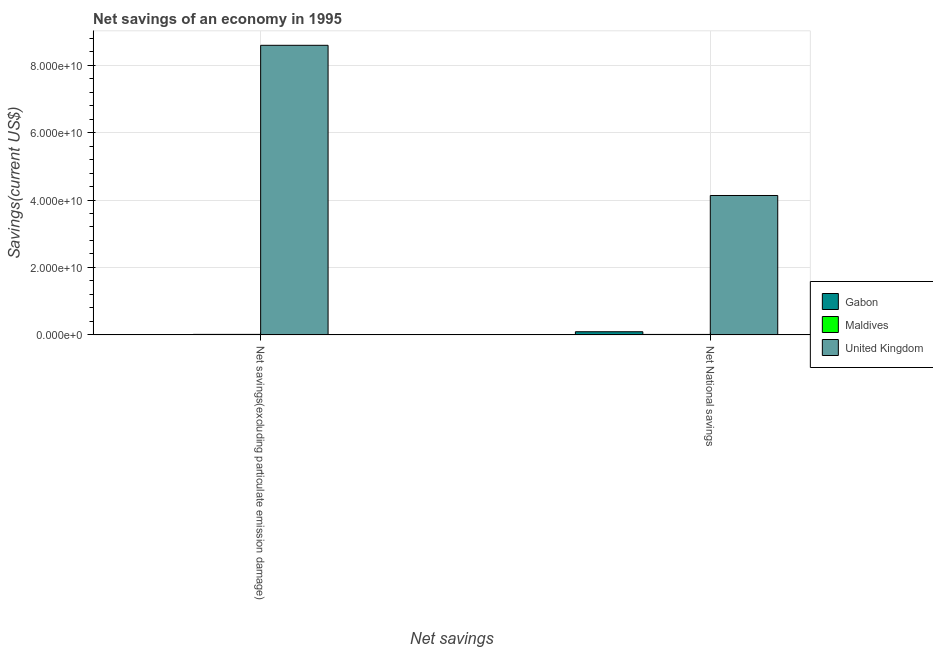How many groups of bars are there?
Provide a short and direct response. 2. Are the number of bars on each tick of the X-axis equal?
Keep it short and to the point. No. How many bars are there on the 1st tick from the left?
Offer a terse response. 2. What is the label of the 1st group of bars from the left?
Make the answer very short. Net savings(excluding particulate emission damage). What is the net savings(excluding particulate emission damage) in Maldives?
Make the answer very short. 1.51e+08. Across all countries, what is the maximum net national savings?
Provide a short and direct response. 4.13e+1. Across all countries, what is the minimum net savings(excluding particulate emission damage)?
Your answer should be compact. 0. What is the total net national savings in the graph?
Provide a short and direct response. 4.24e+1. What is the difference between the net savings(excluding particulate emission damage) in Maldives and that in United Kingdom?
Your answer should be compact. -8.57e+1. What is the difference between the net savings(excluding particulate emission damage) in United Kingdom and the net national savings in Maldives?
Your response must be concise. 8.58e+1. What is the average net national savings per country?
Keep it short and to the point. 1.41e+1. What is the difference between the net national savings and net savings(excluding particulate emission damage) in United Kingdom?
Your answer should be compact. -4.45e+1. What is the ratio of the net national savings in Maldives to that in United Kingdom?
Provide a succinct answer. 0. Are all the bars in the graph horizontal?
Give a very brief answer. No. How many countries are there in the graph?
Your response must be concise. 3. What is the difference between two consecutive major ticks on the Y-axis?
Keep it short and to the point. 2.00e+1. Are the values on the major ticks of Y-axis written in scientific E-notation?
Provide a succinct answer. Yes. Does the graph contain grids?
Provide a short and direct response. Yes. Where does the legend appear in the graph?
Offer a very short reply. Center right. How many legend labels are there?
Provide a succinct answer. 3. How are the legend labels stacked?
Keep it short and to the point. Vertical. What is the title of the graph?
Keep it short and to the point. Net savings of an economy in 1995. Does "Seychelles" appear as one of the legend labels in the graph?
Give a very brief answer. No. What is the label or title of the X-axis?
Keep it short and to the point. Net savings. What is the label or title of the Y-axis?
Offer a very short reply. Savings(current US$). What is the Savings(current US$) in Gabon in Net savings(excluding particulate emission damage)?
Ensure brevity in your answer.  0. What is the Savings(current US$) of Maldives in Net savings(excluding particulate emission damage)?
Make the answer very short. 1.51e+08. What is the Savings(current US$) in United Kingdom in Net savings(excluding particulate emission damage)?
Keep it short and to the point. 8.59e+1. What is the Savings(current US$) in Gabon in Net National savings?
Make the answer very short. 9.35e+08. What is the Savings(current US$) of Maldives in Net National savings?
Keep it short and to the point. 1.36e+08. What is the Savings(current US$) of United Kingdom in Net National savings?
Provide a succinct answer. 4.13e+1. Across all Net savings, what is the maximum Savings(current US$) of Gabon?
Ensure brevity in your answer.  9.35e+08. Across all Net savings, what is the maximum Savings(current US$) of Maldives?
Provide a succinct answer. 1.51e+08. Across all Net savings, what is the maximum Savings(current US$) in United Kingdom?
Offer a terse response. 8.59e+1. Across all Net savings, what is the minimum Savings(current US$) in Maldives?
Provide a short and direct response. 1.36e+08. Across all Net savings, what is the minimum Savings(current US$) of United Kingdom?
Give a very brief answer. 4.13e+1. What is the total Savings(current US$) in Gabon in the graph?
Keep it short and to the point. 9.35e+08. What is the total Savings(current US$) in Maldives in the graph?
Your answer should be compact. 2.87e+08. What is the total Savings(current US$) of United Kingdom in the graph?
Your response must be concise. 1.27e+11. What is the difference between the Savings(current US$) of Maldives in Net savings(excluding particulate emission damage) and that in Net National savings?
Your response must be concise. 1.50e+07. What is the difference between the Savings(current US$) of United Kingdom in Net savings(excluding particulate emission damage) and that in Net National savings?
Ensure brevity in your answer.  4.45e+1. What is the difference between the Savings(current US$) of Maldives in Net savings(excluding particulate emission damage) and the Savings(current US$) of United Kingdom in Net National savings?
Give a very brief answer. -4.12e+1. What is the average Savings(current US$) of Gabon per Net savings?
Keep it short and to the point. 4.67e+08. What is the average Savings(current US$) of Maldives per Net savings?
Provide a short and direct response. 1.44e+08. What is the average Savings(current US$) of United Kingdom per Net savings?
Ensure brevity in your answer.  6.36e+1. What is the difference between the Savings(current US$) of Maldives and Savings(current US$) of United Kingdom in Net savings(excluding particulate emission damage)?
Your response must be concise. -8.57e+1. What is the difference between the Savings(current US$) of Gabon and Savings(current US$) of Maldives in Net National savings?
Provide a short and direct response. 7.99e+08. What is the difference between the Savings(current US$) of Gabon and Savings(current US$) of United Kingdom in Net National savings?
Your answer should be very brief. -4.04e+1. What is the difference between the Savings(current US$) in Maldives and Savings(current US$) in United Kingdom in Net National savings?
Your answer should be very brief. -4.12e+1. What is the ratio of the Savings(current US$) of Maldives in Net savings(excluding particulate emission damage) to that in Net National savings?
Provide a succinct answer. 1.11. What is the ratio of the Savings(current US$) in United Kingdom in Net savings(excluding particulate emission damage) to that in Net National savings?
Make the answer very short. 2.08. What is the difference between the highest and the second highest Savings(current US$) of Maldives?
Your answer should be very brief. 1.50e+07. What is the difference between the highest and the second highest Savings(current US$) of United Kingdom?
Keep it short and to the point. 4.45e+1. What is the difference between the highest and the lowest Savings(current US$) of Gabon?
Make the answer very short. 9.35e+08. What is the difference between the highest and the lowest Savings(current US$) in Maldives?
Your answer should be compact. 1.50e+07. What is the difference between the highest and the lowest Savings(current US$) in United Kingdom?
Make the answer very short. 4.45e+1. 